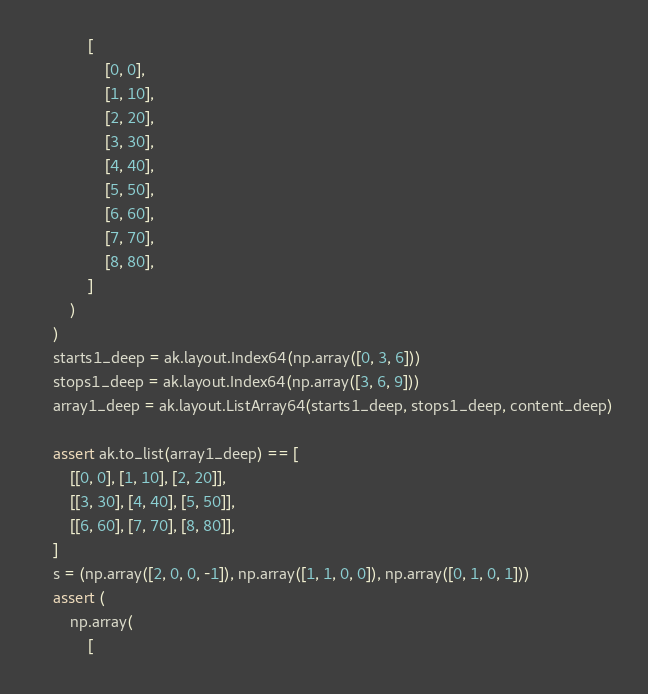<code> <loc_0><loc_0><loc_500><loc_500><_Python_>            [
                [0, 0],
                [1, 10],
                [2, 20],
                [3, 30],
                [4, 40],
                [5, 50],
                [6, 60],
                [7, 70],
                [8, 80],
            ]
        )
    )
    starts1_deep = ak.layout.Index64(np.array([0, 3, 6]))
    stops1_deep = ak.layout.Index64(np.array([3, 6, 9]))
    array1_deep = ak.layout.ListArray64(starts1_deep, stops1_deep, content_deep)

    assert ak.to_list(array1_deep) == [
        [[0, 0], [1, 10], [2, 20]],
        [[3, 30], [4, 40], [5, 50]],
        [[6, 60], [7, 70], [8, 80]],
    ]
    s = (np.array([2, 0, 0, -1]), np.array([1, 1, 0, 0]), np.array([0, 1, 0, 1]))
    assert (
        np.array(
            [</code> 